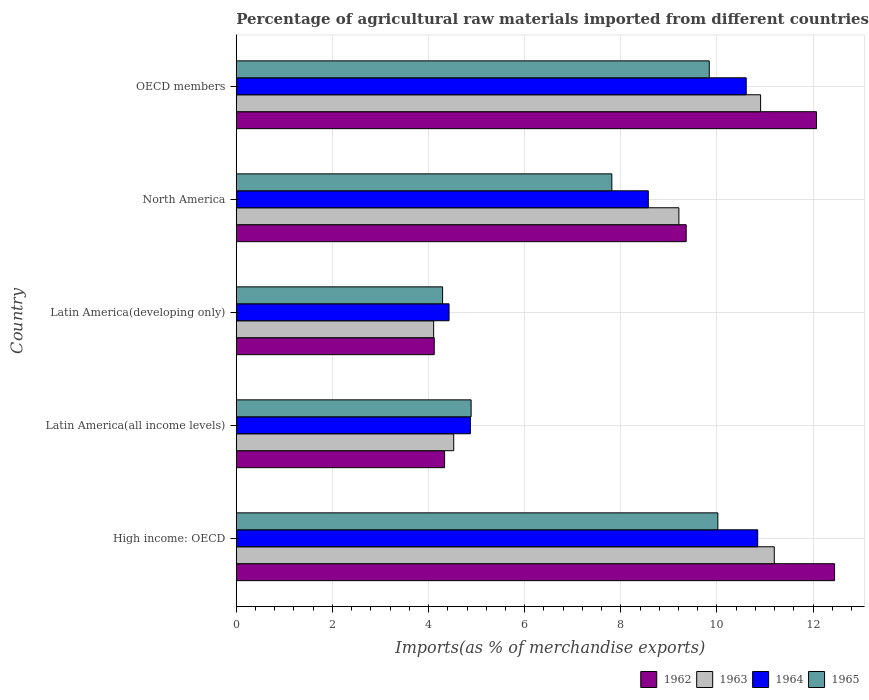How many different coloured bars are there?
Keep it short and to the point. 4. How many groups of bars are there?
Offer a terse response. 5. How many bars are there on the 5th tick from the top?
Offer a terse response. 4. How many bars are there on the 1st tick from the bottom?
Keep it short and to the point. 4. What is the percentage of imports to different countries in 1965 in OECD members?
Your answer should be compact. 9.84. Across all countries, what is the maximum percentage of imports to different countries in 1963?
Provide a succinct answer. 11.19. Across all countries, what is the minimum percentage of imports to different countries in 1965?
Offer a very short reply. 4.29. In which country was the percentage of imports to different countries in 1965 maximum?
Ensure brevity in your answer.  High income: OECD. In which country was the percentage of imports to different countries in 1963 minimum?
Your answer should be compact. Latin America(developing only). What is the total percentage of imports to different countries in 1964 in the graph?
Give a very brief answer. 39.32. What is the difference between the percentage of imports to different countries in 1963 in Latin America(developing only) and that in OECD members?
Give a very brief answer. -6.8. What is the difference between the percentage of imports to different countries in 1965 in Latin America(all income levels) and the percentage of imports to different countries in 1964 in Latin America(developing only)?
Give a very brief answer. 0.46. What is the average percentage of imports to different countries in 1964 per country?
Provide a short and direct response. 7.86. What is the difference between the percentage of imports to different countries in 1962 and percentage of imports to different countries in 1965 in OECD members?
Ensure brevity in your answer.  2.23. What is the ratio of the percentage of imports to different countries in 1962 in Latin America(developing only) to that in OECD members?
Ensure brevity in your answer.  0.34. Is the difference between the percentage of imports to different countries in 1962 in Latin America(developing only) and North America greater than the difference between the percentage of imports to different countries in 1965 in Latin America(developing only) and North America?
Offer a very short reply. No. What is the difference between the highest and the second highest percentage of imports to different countries in 1963?
Keep it short and to the point. 0.28. What is the difference between the highest and the lowest percentage of imports to different countries in 1962?
Ensure brevity in your answer.  8.33. In how many countries, is the percentage of imports to different countries in 1962 greater than the average percentage of imports to different countries in 1962 taken over all countries?
Provide a succinct answer. 3. Is the sum of the percentage of imports to different countries in 1962 in North America and OECD members greater than the maximum percentage of imports to different countries in 1964 across all countries?
Offer a terse response. Yes. Is it the case that in every country, the sum of the percentage of imports to different countries in 1964 and percentage of imports to different countries in 1962 is greater than the sum of percentage of imports to different countries in 1963 and percentage of imports to different countries in 1965?
Make the answer very short. No. What does the 3rd bar from the top in North America represents?
Offer a terse response. 1963. What does the 2nd bar from the bottom in High income: OECD represents?
Your answer should be very brief. 1963. Is it the case that in every country, the sum of the percentage of imports to different countries in 1964 and percentage of imports to different countries in 1965 is greater than the percentage of imports to different countries in 1962?
Your answer should be compact. Yes. How many bars are there?
Provide a succinct answer. 20. What is the difference between two consecutive major ticks on the X-axis?
Offer a terse response. 2. Does the graph contain any zero values?
Provide a succinct answer. No. How many legend labels are there?
Offer a terse response. 4. What is the title of the graph?
Provide a succinct answer. Percentage of agricultural raw materials imported from different countries. What is the label or title of the X-axis?
Your answer should be compact. Imports(as % of merchandise exports). What is the Imports(as % of merchandise exports) in 1962 in High income: OECD?
Your answer should be compact. 12.45. What is the Imports(as % of merchandise exports) in 1963 in High income: OECD?
Make the answer very short. 11.19. What is the Imports(as % of merchandise exports) of 1964 in High income: OECD?
Ensure brevity in your answer.  10.85. What is the Imports(as % of merchandise exports) of 1965 in High income: OECD?
Offer a very short reply. 10.02. What is the Imports(as % of merchandise exports) of 1962 in Latin America(all income levels)?
Offer a terse response. 4.33. What is the Imports(as % of merchandise exports) of 1963 in Latin America(all income levels)?
Give a very brief answer. 4.52. What is the Imports(as % of merchandise exports) of 1964 in Latin America(all income levels)?
Offer a very short reply. 4.87. What is the Imports(as % of merchandise exports) of 1965 in Latin America(all income levels)?
Make the answer very short. 4.89. What is the Imports(as % of merchandise exports) of 1962 in Latin America(developing only)?
Your answer should be very brief. 4.12. What is the Imports(as % of merchandise exports) of 1963 in Latin America(developing only)?
Ensure brevity in your answer.  4.11. What is the Imports(as % of merchandise exports) of 1964 in Latin America(developing only)?
Keep it short and to the point. 4.43. What is the Imports(as % of merchandise exports) in 1965 in Latin America(developing only)?
Your answer should be very brief. 4.29. What is the Imports(as % of merchandise exports) in 1962 in North America?
Your response must be concise. 9.36. What is the Imports(as % of merchandise exports) in 1963 in North America?
Offer a very short reply. 9.21. What is the Imports(as % of merchandise exports) of 1964 in North America?
Offer a terse response. 8.57. What is the Imports(as % of merchandise exports) of 1965 in North America?
Provide a succinct answer. 7.81. What is the Imports(as % of merchandise exports) of 1962 in OECD members?
Offer a terse response. 12.07. What is the Imports(as % of merchandise exports) of 1963 in OECD members?
Offer a terse response. 10.91. What is the Imports(as % of merchandise exports) in 1964 in OECD members?
Your response must be concise. 10.61. What is the Imports(as % of merchandise exports) of 1965 in OECD members?
Provide a succinct answer. 9.84. Across all countries, what is the maximum Imports(as % of merchandise exports) in 1962?
Offer a terse response. 12.45. Across all countries, what is the maximum Imports(as % of merchandise exports) of 1963?
Offer a very short reply. 11.19. Across all countries, what is the maximum Imports(as % of merchandise exports) of 1964?
Ensure brevity in your answer.  10.85. Across all countries, what is the maximum Imports(as % of merchandise exports) in 1965?
Offer a very short reply. 10.02. Across all countries, what is the minimum Imports(as % of merchandise exports) in 1962?
Give a very brief answer. 4.12. Across all countries, what is the minimum Imports(as % of merchandise exports) in 1963?
Your answer should be compact. 4.11. Across all countries, what is the minimum Imports(as % of merchandise exports) in 1964?
Keep it short and to the point. 4.43. Across all countries, what is the minimum Imports(as % of merchandise exports) of 1965?
Your answer should be compact. 4.29. What is the total Imports(as % of merchandise exports) in 1962 in the graph?
Offer a very short reply. 42.33. What is the total Imports(as % of merchandise exports) of 1963 in the graph?
Give a very brief answer. 39.94. What is the total Imports(as % of merchandise exports) in 1964 in the graph?
Your answer should be compact. 39.32. What is the total Imports(as % of merchandise exports) of 1965 in the graph?
Your answer should be compact. 36.85. What is the difference between the Imports(as % of merchandise exports) of 1962 in High income: OECD and that in Latin America(all income levels)?
Offer a terse response. 8.11. What is the difference between the Imports(as % of merchandise exports) of 1963 in High income: OECD and that in Latin America(all income levels)?
Your response must be concise. 6.67. What is the difference between the Imports(as % of merchandise exports) of 1964 in High income: OECD and that in Latin America(all income levels)?
Keep it short and to the point. 5.98. What is the difference between the Imports(as % of merchandise exports) of 1965 in High income: OECD and that in Latin America(all income levels)?
Keep it short and to the point. 5.13. What is the difference between the Imports(as % of merchandise exports) in 1962 in High income: OECD and that in Latin America(developing only)?
Provide a succinct answer. 8.33. What is the difference between the Imports(as % of merchandise exports) in 1963 in High income: OECD and that in Latin America(developing only)?
Offer a very short reply. 7.09. What is the difference between the Imports(as % of merchandise exports) of 1964 in High income: OECD and that in Latin America(developing only)?
Give a very brief answer. 6.42. What is the difference between the Imports(as % of merchandise exports) of 1965 in High income: OECD and that in Latin America(developing only)?
Make the answer very short. 5.73. What is the difference between the Imports(as % of merchandise exports) of 1962 in High income: OECD and that in North America?
Offer a terse response. 3.09. What is the difference between the Imports(as % of merchandise exports) of 1963 in High income: OECD and that in North America?
Your answer should be very brief. 1.98. What is the difference between the Imports(as % of merchandise exports) in 1964 in High income: OECD and that in North America?
Provide a succinct answer. 2.28. What is the difference between the Imports(as % of merchandise exports) in 1965 in High income: OECD and that in North America?
Offer a very short reply. 2.21. What is the difference between the Imports(as % of merchandise exports) of 1962 in High income: OECD and that in OECD members?
Offer a very short reply. 0.38. What is the difference between the Imports(as % of merchandise exports) in 1963 in High income: OECD and that in OECD members?
Offer a very short reply. 0.28. What is the difference between the Imports(as % of merchandise exports) in 1964 in High income: OECD and that in OECD members?
Your answer should be compact. 0.24. What is the difference between the Imports(as % of merchandise exports) of 1965 in High income: OECD and that in OECD members?
Keep it short and to the point. 0.18. What is the difference between the Imports(as % of merchandise exports) of 1962 in Latin America(all income levels) and that in Latin America(developing only)?
Give a very brief answer. 0.22. What is the difference between the Imports(as % of merchandise exports) in 1963 in Latin America(all income levels) and that in Latin America(developing only)?
Provide a short and direct response. 0.42. What is the difference between the Imports(as % of merchandise exports) of 1964 in Latin America(all income levels) and that in Latin America(developing only)?
Provide a short and direct response. 0.44. What is the difference between the Imports(as % of merchandise exports) in 1965 in Latin America(all income levels) and that in Latin America(developing only)?
Ensure brevity in your answer.  0.59. What is the difference between the Imports(as % of merchandise exports) in 1962 in Latin America(all income levels) and that in North America?
Keep it short and to the point. -5.03. What is the difference between the Imports(as % of merchandise exports) in 1963 in Latin America(all income levels) and that in North America?
Your answer should be very brief. -4.68. What is the difference between the Imports(as % of merchandise exports) in 1964 in Latin America(all income levels) and that in North America?
Your answer should be very brief. -3.7. What is the difference between the Imports(as % of merchandise exports) of 1965 in Latin America(all income levels) and that in North America?
Provide a succinct answer. -2.93. What is the difference between the Imports(as % of merchandise exports) of 1962 in Latin America(all income levels) and that in OECD members?
Make the answer very short. -7.74. What is the difference between the Imports(as % of merchandise exports) of 1963 in Latin America(all income levels) and that in OECD members?
Your answer should be compact. -6.38. What is the difference between the Imports(as % of merchandise exports) in 1964 in Latin America(all income levels) and that in OECD members?
Make the answer very short. -5.74. What is the difference between the Imports(as % of merchandise exports) in 1965 in Latin America(all income levels) and that in OECD members?
Offer a terse response. -4.95. What is the difference between the Imports(as % of merchandise exports) in 1962 in Latin America(developing only) and that in North America?
Your answer should be very brief. -5.24. What is the difference between the Imports(as % of merchandise exports) in 1963 in Latin America(developing only) and that in North America?
Provide a succinct answer. -5.1. What is the difference between the Imports(as % of merchandise exports) of 1964 in Latin America(developing only) and that in North America?
Ensure brevity in your answer.  -4.15. What is the difference between the Imports(as % of merchandise exports) of 1965 in Latin America(developing only) and that in North America?
Keep it short and to the point. -3.52. What is the difference between the Imports(as % of merchandise exports) in 1962 in Latin America(developing only) and that in OECD members?
Offer a very short reply. -7.95. What is the difference between the Imports(as % of merchandise exports) in 1963 in Latin America(developing only) and that in OECD members?
Your answer should be compact. -6.8. What is the difference between the Imports(as % of merchandise exports) in 1964 in Latin America(developing only) and that in OECD members?
Provide a short and direct response. -6.18. What is the difference between the Imports(as % of merchandise exports) of 1965 in Latin America(developing only) and that in OECD members?
Your response must be concise. -5.55. What is the difference between the Imports(as % of merchandise exports) in 1962 in North America and that in OECD members?
Your response must be concise. -2.71. What is the difference between the Imports(as % of merchandise exports) of 1963 in North America and that in OECD members?
Your answer should be compact. -1.7. What is the difference between the Imports(as % of merchandise exports) in 1964 in North America and that in OECD members?
Provide a succinct answer. -2.04. What is the difference between the Imports(as % of merchandise exports) of 1965 in North America and that in OECD members?
Offer a very short reply. -2.03. What is the difference between the Imports(as % of merchandise exports) of 1962 in High income: OECD and the Imports(as % of merchandise exports) of 1963 in Latin America(all income levels)?
Your response must be concise. 7.92. What is the difference between the Imports(as % of merchandise exports) of 1962 in High income: OECD and the Imports(as % of merchandise exports) of 1964 in Latin America(all income levels)?
Give a very brief answer. 7.58. What is the difference between the Imports(as % of merchandise exports) in 1962 in High income: OECD and the Imports(as % of merchandise exports) in 1965 in Latin America(all income levels)?
Your answer should be very brief. 7.56. What is the difference between the Imports(as % of merchandise exports) in 1963 in High income: OECD and the Imports(as % of merchandise exports) in 1964 in Latin America(all income levels)?
Your answer should be compact. 6.32. What is the difference between the Imports(as % of merchandise exports) of 1963 in High income: OECD and the Imports(as % of merchandise exports) of 1965 in Latin America(all income levels)?
Offer a terse response. 6.31. What is the difference between the Imports(as % of merchandise exports) in 1964 in High income: OECD and the Imports(as % of merchandise exports) in 1965 in Latin America(all income levels)?
Give a very brief answer. 5.96. What is the difference between the Imports(as % of merchandise exports) in 1962 in High income: OECD and the Imports(as % of merchandise exports) in 1963 in Latin America(developing only)?
Provide a short and direct response. 8.34. What is the difference between the Imports(as % of merchandise exports) in 1962 in High income: OECD and the Imports(as % of merchandise exports) in 1964 in Latin America(developing only)?
Keep it short and to the point. 8.02. What is the difference between the Imports(as % of merchandise exports) of 1962 in High income: OECD and the Imports(as % of merchandise exports) of 1965 in Latin America(developing only)?
Your answer should be compact. 8.15. What is the difference between the Imports(as % of merchandise exports) in 1963 in High income: OECD and the Imports(as % of merchandise exports) in 1964 in Latin America(developing only)?
Provide a short and direct response. 6.77. What is the difference between the Imports(as % of merchandise exports) in 1963 in High income: OECD and the Imports(as % of merchandise exports) in 1965 in Latin America(developing only)?
Offer a terse response. 6.9. What is the difference between the Imports(as % of merchandise exports) of 1964 in High income: OECD and the Imports(as % of merchandise exports) of 1965 in Latin America(developing only)?
Your response must be concise. 6.55. What is the difference between the Imports(as % of merchandise exports) in 1962 in High income: OECD and the Imports(as % of merchandise exports) in 1963 in North America?
Provide a short and direct response. 3.24. What is the difference between the Imports(as % of merchandise exports) in 1962 in High income: OECD and the Imports(as % of merchandise exports) in 1964 in North America?
Provide a succinct answer. 3.87. What is the difference between the Imports(as % of merchandise exports) of 1962 in High income: OECD and the Imports(as % of merchandise exports) of 1965 in North America?
Your answer should be compact. 4.63. What is the difference between the Imports(as % of merchandise exports) in 1963 in High income: OECD and the Imports(as % of merchandise exports) in 1964 in North America?
Keep it short and to the point. 2.62. What is the difference between the Imports(as % of merchandise exports) of 1963 in High income: OECD and the Imports(as % of merchandise exports) of 1965 in North America?
Provide a short and direct response. 3.38. What is the difference between the Imports(as % of merchandise exports) in 1964 in High income: OECD and the Imports(as % of merchandise exports) in 1965 in North America?
Your response must be concise. 3.03. What is the difference between the Imports(as % of merchandise exports) in 1962 in High income: OECD and the Imports(as % of merchandise exports) in 1963 in OECD members?
Give a very brief answer. 1.54. What is the difference between the Imports(as % of merchandise exports) of 1962 in High income: OECD and the Imports(as % of merchandise exports) of 1964 in OECD members?
Your answer should be compact. 1.84. What is the difference between the Imports(as % of merchandise exports) in 1962 in High income: OECD and the Imports(as % of merchandise exports) in 1965 in OECD members?
Offer a very short reply. 2.61. What is the difference between the Imports(as % of merchandise exports) of 1963 in High income: OECD and the Imports(as % of merchandise exports) of 1964 in OECD members?
Your response must be concise. 0.58. What is the difference between the Imports(as % of merchandise exports) in 1963 in High income: OECD and the Imports(as % of merchandise exports) in 1965 in OECD members?
Provide a succinct answer. 1.35. What is the difference between the Imports(as % of merchandise exports) of 1964 in High income: OECD and the Imports(as % of merchandise exports) of 1965 in OECD members?
Provide a short and direct response. 1.01. What is the difference between the Imports(as % of merchandise exports) in 1962 in Latin America(all income levels) and the Imports(as % of merchandise exports) in 1963 in Latin America(developing only)?
Your response must be concise. 0.23. What is the difference between the Imports(as % of merchandise exports) of 1962 in Latin America(all income levels) and the Imports(as % of merchandise exports) of 1964 in Latin America(developing only)?
Keep it short and to the point. -0.09. What is the difference between the Imports(as % of merchandise exports) of 1962 in Latin America(all income levels) and the Imports(as % of merchandise exports) of 1965 in Latin America(developing only)?
Keep it short and to the point. 0.04. What is the difference between the Imports(as % of merchandise exports) in 1963 in Latin America(all income levels) and the Imports(as % of merchandise exports) in 1964 in Latin America(developing only)?
Give a very brief answer. 0.1. What is the difference between the Imports(as % of merchandise exports) of 1963 in Latin America(all income levels) and the Imports(as % of merchandise exports) of 1965 in Latin America(developing only)?
Ensure brevity in your answer.  0.23. What is the difference between the Imports(as % of merchandise exports) in 1964 in Latin America(all income levels) and the Imports(as % of merchandise exports) in 1965 in Latin America(developing only)?
Provide a succinct answer. 0.58. What is the difference between the Imports(as % of merchandise exports) in 1962 in Latin America(all income levels) and the Imports(as % of merchandise exports) in 1963 in North America?
Offer a very short reply. -4.87. What is the difference between the Imports(as % of merchandise exports) of 1962 in Latin America(all income levels) and the Imports(as % of merchandise exports) of 1964 in North America?
Your answer should be compact. -4.24. What is the difference between the Imports(as % of merchandise exports) of 1962 in Latin America(all income levels) and the Imports(as % of merchandise exports) of 1965 in North America?
Provide a succinct answer. -3.48. What is the difference between the Imports(as % of merchandise exports) of 1963 in Latin America(all income levels) and the Imports(as % of merchandise exports) of 1964 in North America?
Your response must be concise. -4.05. What is the difference between the Imports(as % of merchandise exports) in 1963 in Latin America(all income levels) and the Imports(as % of merchandise exports) in 1965 in North America?
Give a very brief answer. -3.29. What is the difference between the Imports(as % of merchandise exports) in 1964 in Latin America(all income levels) and the Imports(as % of merchandise exports) in 1965 in North America?
Ensure brevity in your answer.  -2.94. What is the difference between the Imports(as % of merchandise exports) in 1962 in Latin America(all income levels) and the Imports(as % of merchandise exports) in 1963 in OECD members?
Give a very brief answer. -6.57. What is the difference between the Imports(as % of merchandise exports) of 1962 in Latin America(all income levels) and the Imports(as % of merchandise exports) of 1964 in OECD members?
Make the answer very short. -6.27. What is the difference between the Imports(as % of merchandise exports) of 1962 in Latin America(all income levels) and the Imports(as % of merchandise exports) of 1965 in OECD members?
Keep it short and to the point. -5.51. What is the difference between the Imports(as % of merchandise exports) of 1963 in Latin America(all income levels) and the Imports(as % of merchandise exports) of 1964 in OECD members?
Provide a succinct answer. -6.08. What is the difference between the Imports(as % of merchandise exports) in 1963 in Latin America(all income levels) and the Imports(as % of merchandise exports) in 1965 in OECD members?
Keep it short and to the point. -5.32. What is the difference between the Imports(as % of merchandise exports) in 1964 in Latin America(all income levels) and the Imports(as % of merchandise exports) in 1965 in OECD members?
Your response must be concise. -4.97. What is the difference between the Imports(as % of merchandise exports) of 1962 in Latin America(developing only) and the Imports(as % of merchandise exports) of 1963 in North America?
Offer a very short reply. -5.09. What is the difference between the Imports(as % of merchandise exports) in 1962 in Latin America(developing only) and the Imports(as % of merchandise exports) in 1964 in North America?
Your response must be concise. -4.45. What is the difference between the Imports(as % of merchandise exports) of 1962 in Latin America(developing only) and the Imports(as % of merchandise exports) of 1965 in North America?
Offer a very short reply. -3.69. What is the difference between the Imports(as % of merchandise exports) in 1963 in Latin America(developing only) and the Imports(as % of merchandise exports) in 1964 in North America?
Offer a very short reply. -4.47. What is the difference between the Imports(as % of merchandise exports) of 1963 in Latin America(developing only) and the Imports(as % of merchandise exports) of 1965 in North America?
Give a very brief answer. -3.71. What is the difference between the Imports(as % of merchandise exports) in 1964 in Latin America(developing only) and the Imports(as % of merchandise exports) in 1965 in North America?
Make the answer very short. -3.39. What is the difference between the Imports(as % of merchandise exports) of 1962 in Latin America(developing only) and the Imports(as % of merchandise exports) of 1963 in OECD members?
Offer a terse response. -6.79. What is the difference between the Imports(as % of merchandise exports) of 1962 in Latin America(developing only) and the Imports(as % of merchandise exports) of 1964 in OECD members?
Your answer should be very brief. -6.49. What is the difference between the Imports(as % of merchandise exports) of 1962 in Latin America(developing only) and the Imports(as % of merchandise exports) of 1965 in OECD members?
Make the answer very short. -5.72. What is the difference between the Imports(as % of merchandise exports) in 1963 in Latin America(developing only) and the Imports(as % of merchandise exports) in 1964 in OECD members?
Your answer should be very brief. -6.5. What is the difference between the Imports(as % of merchandise exports) in 1963 in Latin America(developing only) and the Imports(as % of merchandise exports) in 1965 in OECD members?
Your answer should be very brief. -5.73. What is the difference between the Imports(as % of merchandise exports) of 1964 in Latin America(developing only) and the Imports(as % of merchandise exports) of 1965 in OECD members?
Your answer should be very brief. -5.41. What is the difference between the Imports(as % of merchandise exports) in 1962 in North America and the Imports(as % of merchandise exports) in 1963 in OECD members?
Offer a very short reply. -1.55. What is the difference between the Imports(as % of merchandise exports) of 1962 in North America and the Imports(as % of merchandise exports) of 1964 in OECD members?
Your response must be concise. -1.25. What is the difference between the Imports(as % of merchandise exports) in 1962 in North America and the Imports(as % of merchandise exports) in 1965 in OECD members?
Give a very brief answer. -0.48. What is the difference between the Imports(as % of merchandise exports) in 1963 in North America and the Imports(as % of merchandise exports) in 1964 in OECD members?
Offer a terse response. -1.4. What is the difference between the Imports(as % of merchandise exports) in 1963 in North America and the Imports(as % of merchandise exports) in 1965 in OECD members?
Ensure brevity in your answer.  -0.63. What is the difference between the Imports(as % of merchandise exports) in 1964 in North America and the Imports(as % of merchandise exports) in 1965 in OECD members?
Your answer should be compact. -1.27. What is the average Imports(as % of merchandise exports) of 1962 per country?
Provide a succinct answer. 8.47. What is the average Imports(as % of merchandise exports) of 1963 per country?
Provide a short and direct response. 7.99. What is the average Imports(as % of merchandise exports) in 1964 per country?
Your answer should be compact. 7.86. What is the average Imports(as % of merchandise exports) of 1965 per country?
Ensure brevity in your answer.  7.37. What is the difference between the Imports(as % of merchandise exports) of 1962 and Imports(as % of merchandise exports) of 1963 in High income: OECD?
Your answer should be very brief. 1.25. What is the difference between the Imports(as % of merchandise exports) of 1962 and Imports(as % of merchandise exports) of 1964 in High income: OECD?
Give a very brief answer. 1.6. What is the difference between the Imports(as % of merchandise exports) in 1962 and Imports(as % of merchandise exports) in 1965 in High income: OECD?
Your answer should be compact. 2.43. What is the difference between the Imports(as % of merchandise exports) in 1963 and Imports(as % of merchandise exports) in 1964 in High income: OECD?
Offer a very short reply. 0.34. What is the difference between the Imports(as % of merchandise exports) in 1963 and Imports(as % of merchandise exports) in 1965 in High income: OECD?
Ensure brevity in your answer.  1.17. What is the difference between the Imports(as % of merchandise exports) in 1964 and Imports(as % of merchandise exports) in 1965 in High income: OECD?
Provide a succinct answer. 0.83. What is the difference between the Imports(as % of merchandise exports) in 1962 and Imports(as % of merchandise exports) in 1963 in Latin America(all income levels)?
Keep it short and to the point. -0.19. What is the difference between the Imports(as % of merchandise exports) in 1962 and Imports(as % of merchandise exports) in 1964 in Latin America(all income levels)?
Provide a short and direct response. -0.54. What is the difference between the Imports(as % of merchandise exports) in 1962 and Imports(as % of merchandise exports) in 1965 in Latin America(all income levels)?
Give a very brief answer. -0.55. What is the difference between the Imports(as % of merchandise exports) in 1963 and Imports(as % of merchandise exports) in 1964 in Latin America(all income levels)?
Your answer should be compact. -0.35. What is the difference between the Imports(as % of merchandise exports) of 1963 and Imports(as % of merchandise exports) of 1965 in Latin America(all income levels)?
Provide a succinct answer. -0.36. What is the difference between the Imports(as % of merchandise exports) in 1964 and Imports(as % of merchandise exports) in 1965 in Latin America(all income levels)?
Make the answer very short. -0.02. What is the difference between the Imports(as % of merchandise exports) of 1962 and Imports(as % of merchandise exports) of 1963 in Latin America(developing only)?
Your response must be concise. 0.01. What is the difference between the Imports(as % of merchandise exports) in 1962 and Imports(as % of merchandise exports) in 1964 in Latin America(developing only)?
Your answer should be compact. -0.31. What is the difference between the Imports(as % of merchandise exports) of 1962 and Imports(as % of merchandise exports) of 1965 in Latin America(developing only)?
Your response must be concise. -0.17. What is the difference between the Imports(as % of merchandise exports) of 1963 and Imports(as % of merchandise exports) of 1964 in Latin America(developing only)?
Keep it short and to the point. -0.32. What is the difference between the Imports(as % of merchandise exports) of 1963 and Imports(as % of merchandise exports) of 1965 in Latin America(developing only)?
Your response must be concise. -0.19. What is the difference between the Imports(as % of merchandise exports) of 1964 and Imports(as % of merchandise exports) of 1965 in Latin America(developing only)?
Ensure brevity in your answer.  0.13. What is the difference between the Imports(as % of merchandise exports) of 1962 and Imports(as % of merchandise exports) of 1963 in North America?
Ensure brevity in your answer.  0.15. What is the difference between the Imports(as % of merchandise exports) in 1962 and Imports(as % of merchandise exports) in 1964 in North America?
Provide a short and direct response. 0.79. What is the difference between the Imports(as % of merchandise exports) of 1962 and Imports(as % of merchandise exports) of 1965 in North America?
Your answer should be very brief. 1.55. What is the difference between the Imports(as % of merchandise exports) in 1963 and Imports(as % of merchandise exports) in 1964 in North America?
Make the answer very short. 0.64. What is the difference between the Imports(as % of merchandise exports) in 1963 and Imports(as % of merchandise exports) in 1965 in North America?
Your response must be concise. 1.39. What is the difference between the Imports(as % of merchandise exports) in 1964 and Imports(as % of merchandise exports) in 1965 in North America?
Make the answer very short. 0.76. What is the difference between the Imports(as % of merchandise exports) in 1962 and Imports(as % of merchandise exports) in 1963 in OECD members?
Your response must be concise. 1.16. What is the difference between the Imports(as % of merchandise exports) of 1962 and Imports(as % of merchandise exports) of 1964 in OECD members?
Ensure brevity in your answer.  1.46. What is the difference between the Imports(as % of merchandise exports) in 1962 and Imports(as % of merchandise exports) in 1965 in OECD members?
Keep it short and to the point. 2.23. What is the difference between the Imports(as % of merchandise exports) of 1963 and Imports(as % of merchandise exports) of 1964 in OECD members?
Your answer should be very brief. 0.3. What is the difference between the Imports(as % of merchandise exports) in 1963 and Imports(as % of merchandise exports) in 1965 in OECD members?
Provide a short and direct response. 1.07. What is the difference between the Imports(as % of merchandise exports) in 1964 and Imports(as % of merchandise exports) in 1965 in OECD members?
Your answer should be compact. 0.77. What is the ratio of the Imports(as % of merchandise exports) in 1962 in High income: OECD to that in Latin America(all income levels)?
Your answer should be very brief. 2.87. What is the ratio of the Imports(as % of merchandise exports) of 1963 in High income: OECD to that in Latin America(all income levels)?
Keep it short and to the point. 2.47. What is the ratio of the Imports(as % of merchandise exports) in 1964 in High income: OECD to that in Latin America(all income levels)?
Your answer should be very brief. 2.23. What is the ratio of the Imports(as % of merchandise exports) in 1965 in High income: OECD to that in Latin America(all income levels)?
Provide a short and direct response. 2.05. What is the ratio of the Imports(as % of merchandise exports) of 1962 in High income: OECD to that in Latin America(developing only)?
Offer a terse response. 3.02. What is the ratio of the Imports(as % of merchandise exports) in 1963 in High income: OECD to that in Latin America(developing only)?
Give a very brief answer. 2.73. What is the ratio of the Imports(as % of merchandise exports) of 1964 in High income: OECD to that in Latin America(developing only)?
Your answer should be compact. 2.45. What is the ratio of the Imports(as % of merchandise exports) of 1965 in High income: OECD to that in Latin America(developing only)?
Your answer should be very brief. 2.33. What is the ratio of the Imports(as % of merchandise exports) of 1962 in High income: OECD to that in North America?
Keep it short and to the point. 1.33. What is the ratio of the Imports(as % of merchandise exports) in 1963 in High income: OECD to that in North America?
Ensure brevity in your answer.  1.22. What is the ratio of the Imports(as % of merchandise exports) of 1964 in High income: OECD to that in North America?
Make the answer very short. 1.27. What is the ratio of the Imports(as % of merchandise exports) in 1965 in High income: OECD to that in North America?
Make the answer very short. 1.28. What is the ratio of the Imports(as % of merchandise exports) in 1962 in High income: OECD to that in OECD members?
Provide a succinct answer. 1.03. What is the ratio of the Imports(as % of merchandise exports) of 1963 in High income: OECD to that in OECD members?
Ensure brevity in your answer.  1.03. What is the ratio of the Imports(as % of merchandise exports) of 1964 in High income: OECD to that in OECD members?
Make the answer very short. 1.02. What is the ratio of the Imports(as % of merchandise exports) of 1965 in High income: OECD to that in OECD members?
Give a very brief answer. 1.02. What is the ratio of the Imports(as % of merchandise exports) in 1962 in Latin America(all income levels) to that in Latin America(developing only)?
Offer a terse response. 1.05. What is the ratio of the Imports(as % of merchandise exports) of 1963 in Latin America(all income levels) to that in Latin America(developing only)?
Your answer should be very brief. 1.1. What is the ratio of the Imports(as % of merchandise exports) in 1964 in Latin America(all income levels) to that in Latin America(developing only)?
Provide a short and direct response. 1.1. What is the ratio of the Imports(as % of merchandise exports) of 1965 in Latin America(all income levels) to that in Latin America(developing only)?
Provide a succinct answer. 1.14. What is the ratio of the Imports(as % of merchandise exports) in 1962 in Latin America(all income levels) to that in North America?
Your response must be concise. 0.46. What is the ratio of the Imports(as % of merchandise exports) in 1963 in Latin America(all income levels) to that in North America?
Provide a succinct answer. 0.49. What is the ratio of the Imports(as % of merchandise exports) of 1964 in Latin America(all income levels) to that in North America?
Your response must be concise. 0.57. What is the ratio of the Imports(as % of merchandise exports) in 1965 in Latin America(all income levels) to that in North America?
Offer a very short reply. 0.63. What is the ratio of the Imports(as % of merchandise exports) of 1962 in Latin America(all income levels) to that in OECD members?
Ensure brevity in your answer.  0.36. What is the ratio of the Imports(as % of merchandise exports) of 1963 in Latin America(all income levels) to that in OECD members?
Ensure brevity in your answer.  0.41. What is the ratio of the Imports(as % of merchandise exports) of 1964 in Latin America(all income levels) to that in OECD members?
Give a very brief answer. 0.46. What is the ratio of the Imports(as % of merchandise exports) in 1965 in Latin America(all income levels) to that in OECD members?
Your answer should be compact. 0.5. What is the ratio of the Imports(as % of merchandise exports) in 1962 in Latin America(developing only) to that in North America?
Your response must be concise. 0.44. What is the ratio of the Imports(as % of merchandise exports) in 1963 in Latin America(developing only) to that in North America?
Keep it short and to the point. 0.45. What is the ratio of the Imports(as % of merchandise exports) in 1964 in Latin America(developing only) to that in North America?
Give a very brief answer. 0.52. What is the ratio of the Imports(as % of merchandise exports) in 1965 in Latin America(developing only) to that in North America?
Keep it short and to the point. 0.55. What is the ratio of the Imports(as % of merchandise exports) in 1962 in Latin America(developing only) to that in OECD members?
Ensure brevity in your answer.  0.34. What is the ratio of the Imports(as % of merchandise exports) in 1963 in Latin America(developing only) to that in OECD members?
Offer a very short reply. 0.38. What is the ratio of the Imports(as % of merchandise exports) in 1964 in Latin America(developing only) to that in OECD members?
Offer a terse response. 0.42. What is the ratio of the Imports(as % of merchandise exports) in 1965 in Latin America(developing only) to that in OECD members?
Your answer should be very brief. 0.44. What is the ratio of the Imports(as % of merchandise exports) in 1962 in North America to that in OECD members?
Your answer should be very brief. 0.78. What is the ratio of the Imports(as % of merchandise exports) in 1963 in North America to that in OECD members?
Provide a short and direct response. 0.84. What is the ratio of the Imports(as % of merchandise exports) of 1964 in North America to that in OECD members?
Provide a short and direct response. 0.81. What is the ratio of the Imports(as % of merchandise exports) of 1965 in North America to that in OECD members?
Your answer should be very brief. 0.79. What is the difference between the highest and the second highest Imports(as % of merchandise exports) of 1962?
Your response must be concise. 0.38. What is the difference between the highest and the second highest Imports(as % of merchandise exports) in 1963?
Make the answer very short. 0.28. What is the difference between the highest and the second highest Imports(as % of merchandise exports) of 1964?
Offer a terse response. 0.24. What is the difference between the highest and the second highest Imports(as % of merchandise exports) of 1965?
Make the answer very short. 0.18. What is the difference between the highest and the lowest Imports(as % of merchandise exports) in 1962?
Your answer should be very brief. 8.33. What is the difference between the highest and the lowest Imports(as % of merchandise exports) in 1963?
Give a very brief answer. 7.09. What is the difference between the highest and the lowest Imports(as % of merchandise exports) of 1964?
Provide a short and direct response. 6.42. What is the difference between the highest and the lowest Imports(as % of merchandise exports) of 1965?
Give a very brief answer. 5.73. 